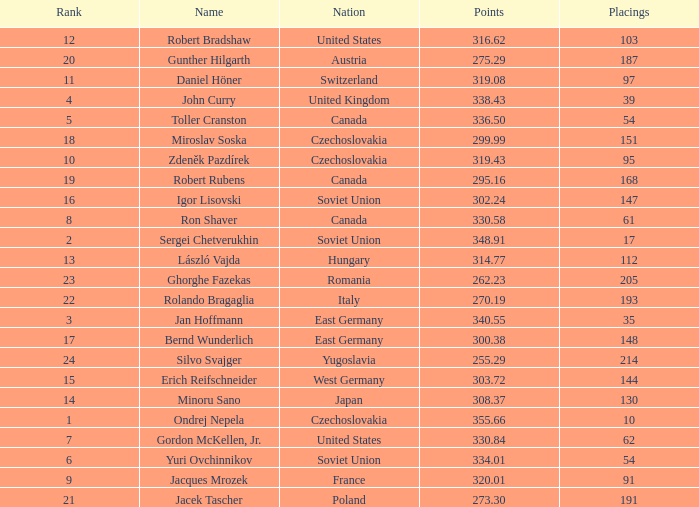Which Nation has Points of 300.38? East Germany. 